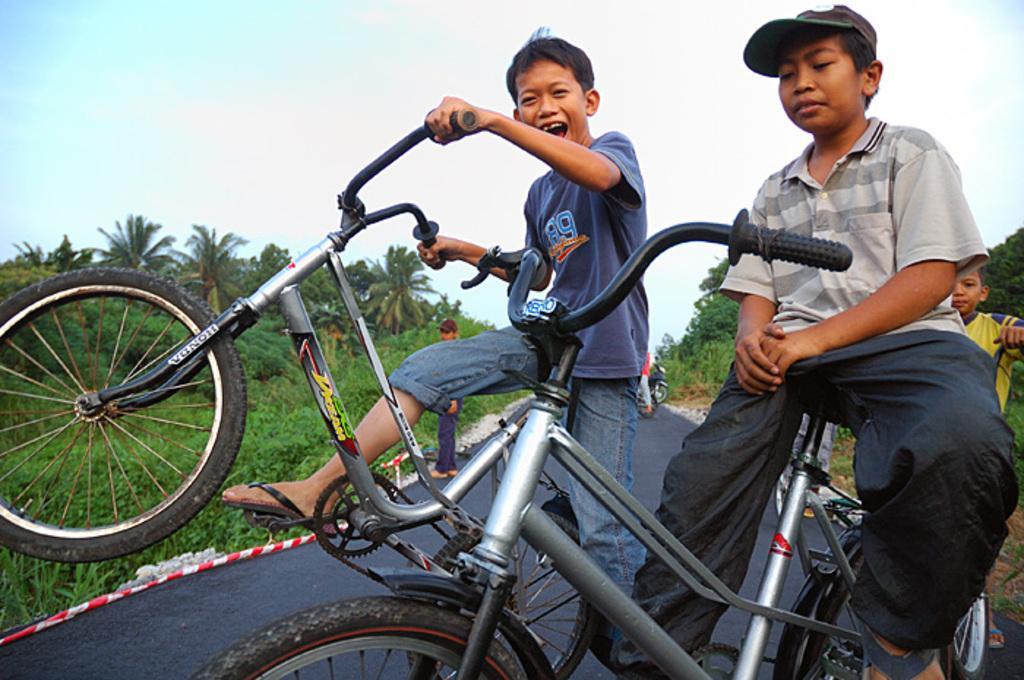How would you summarize this image in a sentence or two? In this image there are two persons are on the bicycle as we can see in middle of this image. There is a road at bottom of this image and there are some trees at left side of this image and right side of this image as well and there is a sky at top of this image. There is one another kid at right side of this image. 